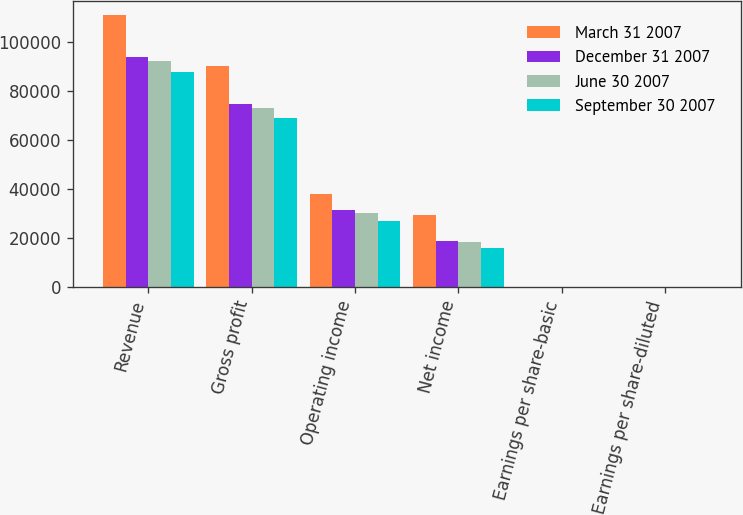Convert chart. <chart><loc_0><loc_0><loc_500><loc_500><stacked_bar_chart><ecel><fcel>Revenue<fcel>Gross profit<fcel>Operating income<fcel>Net income<fcel>Earnings per share-basic<fcel>Earnings per share-diluted<nl><fcel>March 31 2007<fcel>111236<fcel>90391<fcel>37942<fcel>29289<fcel>0.37<fcel>0.36<nl><fcel>December 31 2007<fcel>94034<fcel>74643<fcel>31610<fcel>18696<fcel>0.24<fcel>0.23<nl><fcel>June 30 2007<fcel>92211<fcel>73280<fcel>30396<fcel>18256<fcel>0.24<fcel>0.23<nl><fcel>September 30 2007<fcel>87859<fcel>68979<fcel>26821<fcel>16151<fcel>0.21<fcel>0.2<nl></chart> 